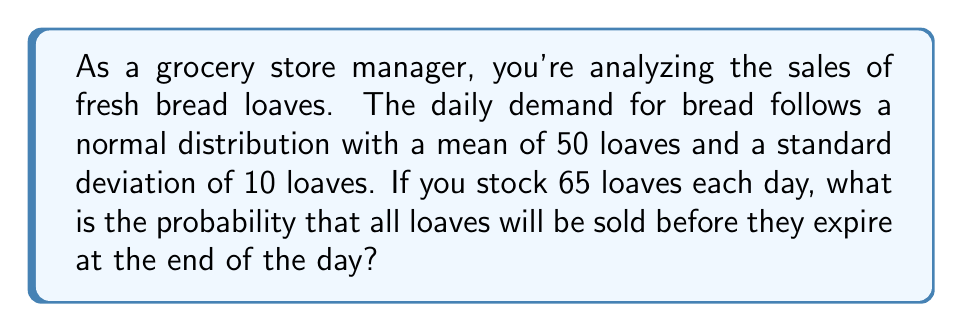Could you help me with this problem? Let's approach this step-by-step:

1) We're dealing with a normal distribution where:
   $\mu = 50$ (mean)
   $\sigma = 10$ (standard deviation)

2) We want to find the probability that demand exceeds 65 loaves.

3) To do this, we need to calculate the z-score for 65 loaves:

   $$z = \frac{x - \mu}{\sigma} = \frac{65 - 50}{10} = 1.5$$

4) Now, we need to find the area under the standard normal curve to the right of z = 1.5.

5) Using a standard normal table or calculator, we can find that:
   P(Z > 1.5) ≈ 0.0668

6) This means there's approximately a 6.68% chance that demand will exceed 65 loaves.

7) Therefore, the probability of selling all 65 loaves before they expire is about 0.0668 or 6.68%.
Answer: 0.0668 